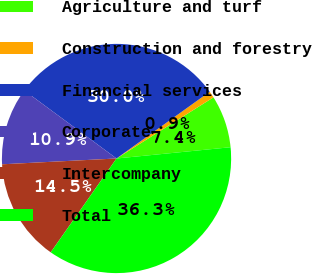<chart> <loc_0><loc_0><loc_500><loc_500><pie_chart><fcel>Agriculture and turf<fcel>Construction and forestry<fcel>Financial services<fcel>Corporate<fcel>Intercompany<fcel>Total<nl><fcel>7.39%<fcel>0.94%<fcel>29.99%<fcel>10.92%<fcel>14.46%<fcel>36.3%<nl></chart> 